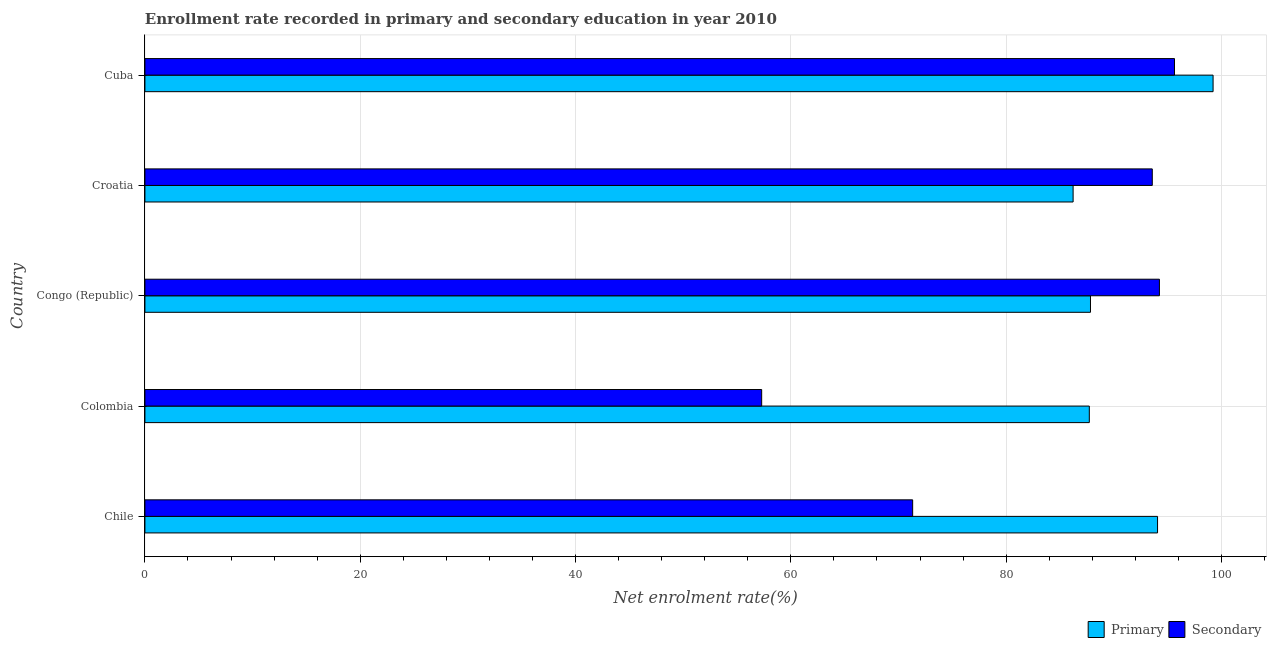How many groups of bars are there?
Provide a short and direct response. 5. Are the number of bars on each tick of the Y-axis equal?
Offer a terse response. Yes. What is the label of the 3rd group of bars from the top?
Your answer should be very brief. Congo (Republic). In how many cases, is the number of bars for a given country not equal to the number of legend labels?
Provide a short and direct response. 0. What is the enrollment rate in primary education in Colombia?
Provide a short and direct response. 87.72. Across all countries, what is the maximum enrollment rate in secondary education?
Your answer should be compact. 95.64. Across all countries, what is the minimum enrollment rate in primary education?
Your answer should be compact. 86.22. In which country was the enrollment rate in secondary education maximum?
Your response must be concise. Cuba. What is the total enrollment rate in primary education in the graph?
Your answer should be very brief. 455.06. What is the difference between the enrollment rate in primary education in Chile and that in Croatia?
Your answer should be very brief. 7.84. What is the difference between the enrollment rate in secondary education in Congo (Republic) and the enrollment rate in primary education in Chile?
Give a very brief answer. 0.17. What is the average enrollment rate in secondary education per country?
Provide a succinct answer. 82.41. What is the difference between the enrollment rate in primary education and enrollment rate in secondary education in Colombia?
Your answer should be compact. 30.43. Is the enrollment rate in secondary education in Chile less than that in Croatia?
Give a very brief answer. Yes. What is the difference between the highest and the second highest enrollment rate in secondary education?
Ensure brevity in your answer.  1.4. Is the sum of the enrollment rate in primary education in Colombia and Congo (Republic) greater than the maximum enrollment rate in secondary education across all countries?
Give a very brief answer. Yes. What does the 1st bar from the top in Colombia represents?
Make the answer very short. Secondary. What does the 1st bar from the bottom in Chile represents?
Give a very brief answer. Primary. Are all the bars in the graph horizontal?
Provide a short and direct response. Yes. How many countries are there in the graph?
Your answer should be compact. 5. Does the graph contain any zero values?
Ensure brevity in your answer.  No. How many legend labels are there?
Provide a short and direct response. 2. What is the title of the graph?
Offer a terse response. Enrollment rate recorded in primary and secondary education in year 2010. What is the label or title of the X-axis?
Offer a terse response. Net enrolment rate(%). What is the label or title of the Y-axis?
Offer a very short reply. Country. What is the Net enrolment rate(%) in Primary in Chile?
Offer a terse response. 94.06. What is the Net enrolment rate(%) of Secondary in Chile?
Keep it short and to the point. 71.31. What is the Net enrolment rate(%) of Primary in Colombia?
Keep it short and to the point. 87.72. What is the Net enrolment rate(%) in Secondary in Colombia?
Provide a short and direct response. 57.29. What is the Net enrolment rate(%) of Primary in Congo (Republic)?
Ensure brevity in your answer.  87.83. What is the Net enrolment rate(%) in Secondary in Congo (Republic)?
Ensure brevity in your answer.  94.24. What is the Net enrolment rate(%) of Primary in Croatia?
Make the answer very short. 86.22. What is the Net enrolment rate(%) in Secondary in Croatia?
Provide a short and direct response. 93.57. What is the Net enrolment rate(%) of Primary in Cuba?
Give a very brief answer. 99.22. What is the Net enrolment rate(%) of Secondary in Cuba?
Keep it short and to the point. 95.64. Across all countries, what is the maximum Net enrolment rate(%) of Primary?
Offer a terse response. 99.22. Across all countries, what is the maximum Net enrolment rate(%) in Secondary?
Your response must be concise. 95.64. Across all countries, what is the minimum Net enrolment rate(%) in Primary?
Your answer should be compact. 86.22. Across all countries, what is the minimum Net enrolment rate(%) of Secondary?
Make the answer very short. 57.29. What is the total Net enrolment rate(%) in Primary in the graph?
Ensure brevity in your answer.  455.06. What is the total Net enrolment rate(%) in Secondary in the graph?
Give a very brief answer. 412.05. What is the difference between the Net enrolment rate(%) of Primary in Chile and that in Colombia?
Ensure brevity in your answer.  6.34. What is the difference between the Net enrolment rate(%) in Secondary in Chile and that in Colombia?
Offer a terse response. 14.02. What is the difference between the Net enrolment rate(%) in Primary in Chile and that in Congo (Republic)?
Provide a succinct answer. 6.23. What is the difference between the Net enrolment rate(%) of Secondary in Chile and that in Congo (Republic)?
Your answer should be compact. -22.92. What is the difference between the Net enrolment rate(%) in Primary in Chile and that in Croatia?
Your answer should be compact. 7.84. What is the difference between the Net enrolment rate(%) in Secondary in Chile and that in Croatia?
Keep it short and to the point. -22.26. What is the difference between the Net enrolment rate(%) in Primary in Chile and that in Cuba?
Provide a short and direct response. -5.16. What is the difference between the Net enrolment rate(%) in Secondary in Chile and that in Cuba?
Offer a very short reply. -24.32. What is the difference between the Net enrolment rate(%) of Primary in Colombia and that in Congo (Republic)?
Offer a very short reply. -0.11. What is the difference between the Net enrolment rate(%) of Secondary in Colombia and that in Congo (Republic)?
Give a very brief answer. -36.95. What is the difference between the Net enrolment rate(%) in Primary in Colombia and that in Croatia?
Your answer should be compact. 1.51. What is the difference between the Net enrolment rate(%) of Secondary in Colombia and that in Croatia?
Keep it short and to the point. -36.28. What is the difference between the Net enrolment rate(%) of Primary in Colombia and that in Cuba?
Your response must be concise. -11.5. What is the difference between the Net enrolment rate(%) of Secondary in Colombia and that in Cuba?
Offer a terse response. -38.35. What is the difference between the Net enrolment rate(%) of Primary in Congo (Republic) and that in Croatia?
Offer a terse response. 1.61. What is the difference between the Net enrolment rate(%) of Secondary in Congo (Republic) and that in Croatia?
Keep it short and to the point. 0.66. What is the difference between the Net enrolment rate(%) of Primary in Congo (Republic) and that in Cuba?
Your response must be concise. -11.39. What is the difference between the Net enrolment rate(%) in Secondary in Congo (Republic) and that in Cuba?
Keep it short and to the point. -1.4. What is the difference between the Net enrolment rate(%) of Primary in Croatia and that in Cuba?
Your answer should be very brief. -13. What is the difference between the Net enrolment rate(%) in Secondary in Croatia and that in Cuba?
Provide a short and direct response. -2.06. What is the difference between the Net enrolment rate(%) in Primary in Chile and the Net enrolment rate(%) in Secondary in Colombia?
Keep it short and to the point. 36.77. What is the difference between the Net enrolment rate(%) in Primary in Chile and the Net enrolment rate(%) in Secondary in Congo (Republic)?
Your answer should be compact. -0.17. What is the difference between the Net enrolment rate(%) in Primary in Chile and the Net enrolment rate(%) in Secondary in Croatia?
Give a very brief answer. 0.49. What is the difference between the Net enrolment rate(%) of Primary in Chile and the Net enrolment rate(%) of Secondary in Cuba?
Make the answer very short. -1.57. What is the difference between the Net enrolment rate(%) in Primary in Colombia and the Net enrolment rate(%) in Secondary in Congo (Republic)?
Give a very brief answer. -6.51. What is the difference between the Net enrolment rate(%) in Primary in Colombia and the Net enrolment rate(%) in Secondary in Croatia?
Offer a very short reply. -5.85. What is the difference between the Net enrolment rate(%) in Primary in Colombia and the Net enrolment rate(%) in Secondary in Cuba?
Keep it short and to the point. -7.91. What is the difference between the Net enrolment rate(%) of Primary in Congo (Republic) and the Net enrolment rate(%) of Secondary in Croatia?
Your response must be concise. -5.74. What is the difference between the Net enrolment rate(%) of Primary in Congo (Republic) and the Net enrolment rate(%) of Secondary in Cuba?
Provide a succinct answer. -7.8. What is the difference between the Net enrolment rate(%) of Primary in Croatia and the Net enrolment rate(%) of Secondary in Cuba?
Your response must be concise. -9.42. What is the average Net enrolment rate(%) of Primary per country?
Offer a very short reply. 91.01. What is the average Net enrolment rate(%) in Secondary per country?
Offer a terse response. 82.41. What is the difference between the Net enrolment rate(%) of Primary and Net enrolment rate(%) of Secondary in Chile?
Ensure brevity in your answer.  22.75. What is the difference between the Net enrolment rate(%) in Primary and Net enrolment rate(%) in Secondary in Colombia?
Provide a succinct answer. 30.43. What is the difference between the Net enrolment rate(%) in Primary and Net enrolment rate(%) in Secondary in Congo (Republic)?
Give a very brief answer. -6.4. What is the difference between the Net enrolment rate(%) of Primary and Net enrolment rate(%) of Secondary in Croatia?
Give a very brief answer. -7.35. What is the difference between the Net enrolment rate(%) of Primary and Net enrolment rate(%) of Secondary in Cuba?
Ensure brevity in your answer.  3.58. What is the ratio of the Net enrolment rate(%) of Primary in Chile to that in Colombia?
Keep it short and to the point. 1.07. What is the ratio of the Net enrolment rate(%) in Secondary in Chile to that in Colombia?
Keep it short and to the point. 1.24. What is the ratio of the Net enrolment rate(%) in Primary in Chile to that in Congo (Republic)?
Offer a terse response. 1.07. What is the ratio of the Net enrolment rate(%) in Secondary in Chile to that in Congo (Republic)?
Make the answer very short. 0.76. What is the ratio of the Net enrolment rate(%) in Primary in Chile to that in Croatia?
Make the answer very short. 1.09. What is the ratio of the Net enrolment rate(%) in Secondary in Chile to that in Croatia?
Your answer should be very brief. 0.76. What is the ratio of the Net enrolment rate(%) of Primary in Chile to that in Cuba?
Your answer should be very brief. 0.95. What is the ratio of the Net enrolment rate(%) of Secondary in Chile to that in Cuba?
Keep it short and to the point. 0.75. What is the ratio of the Net enrolment rate(%) of Secondary in Colombia to that in Congo (Republic)?
Offer a terse response. 0.61. What is the ratio of the Net enrolment rate(%) of Primary in Colombia to that in Croatia?
Provide a short and direct response. 1.02. What is the ratio of the Net enrolment rate(%) of Secondary in Colombia to that in Croatia?
Offer a very short reply. 0.61. What is the ratio of the Net enrolment rate(%) of Primary in Colombia to that in Cuba?
Your answer should be compact. 0.88. What is the ratio of the Net enrolment rate(%) in Secondary in Colombia to that in Cuba?
Provide a short and direct response. 0.6. What is the ratio of the Net enrolment rate(%) of Primary in Congo (Republic) to that in Croatia?
Offer a terse response. 1.02. What is the ratio of the Net enrolment rate(%) of Secondary in Congo (Republic) to that in Croatia?
Offer a terse response. 1.01. What is the ratio of the Net enrolment rate(%) in Primary in Congo (Republic) to that in Cuba?
Give a very brief answer. 0.89. What is the ratio of the Net enrolment rate(%) of Secondary in Congo (Republic) to that in Cuba?
Keep it short and to the point. 0.99. What is the ratio of the Net enrolment rate(%) of Primary in Croatia to that in Cuba?
Give a very brief answer. 0.87. What is the ratio of the Net enrolment rate(%) in Secondary in Croatia to that in Cuba?
Your answer should be compact. 0.98. What is the difference between the highest and the second highest Net enrolment rate(%) in Primary?
Offer a very short reply. 5.16. What is the difference between the highest and the second highest Net enrolment rate(%) in Secondary?
Ensure brevity in your answer.  1.4. What is the difference between the highest and the lowest Net enrolment rate(%) of Primary?
Make the answer very short. 13. What is the difference between the highest and the lowest Net enrolment rate(%) of Secondary?
Your answer should be very brief. 38.35. 